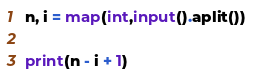Convert code to text. <code><loc_0><loc_0><loc_500><loc_500><_Python_>n, i = map(int,input().aplit())

print(n - i + 1)</code> 